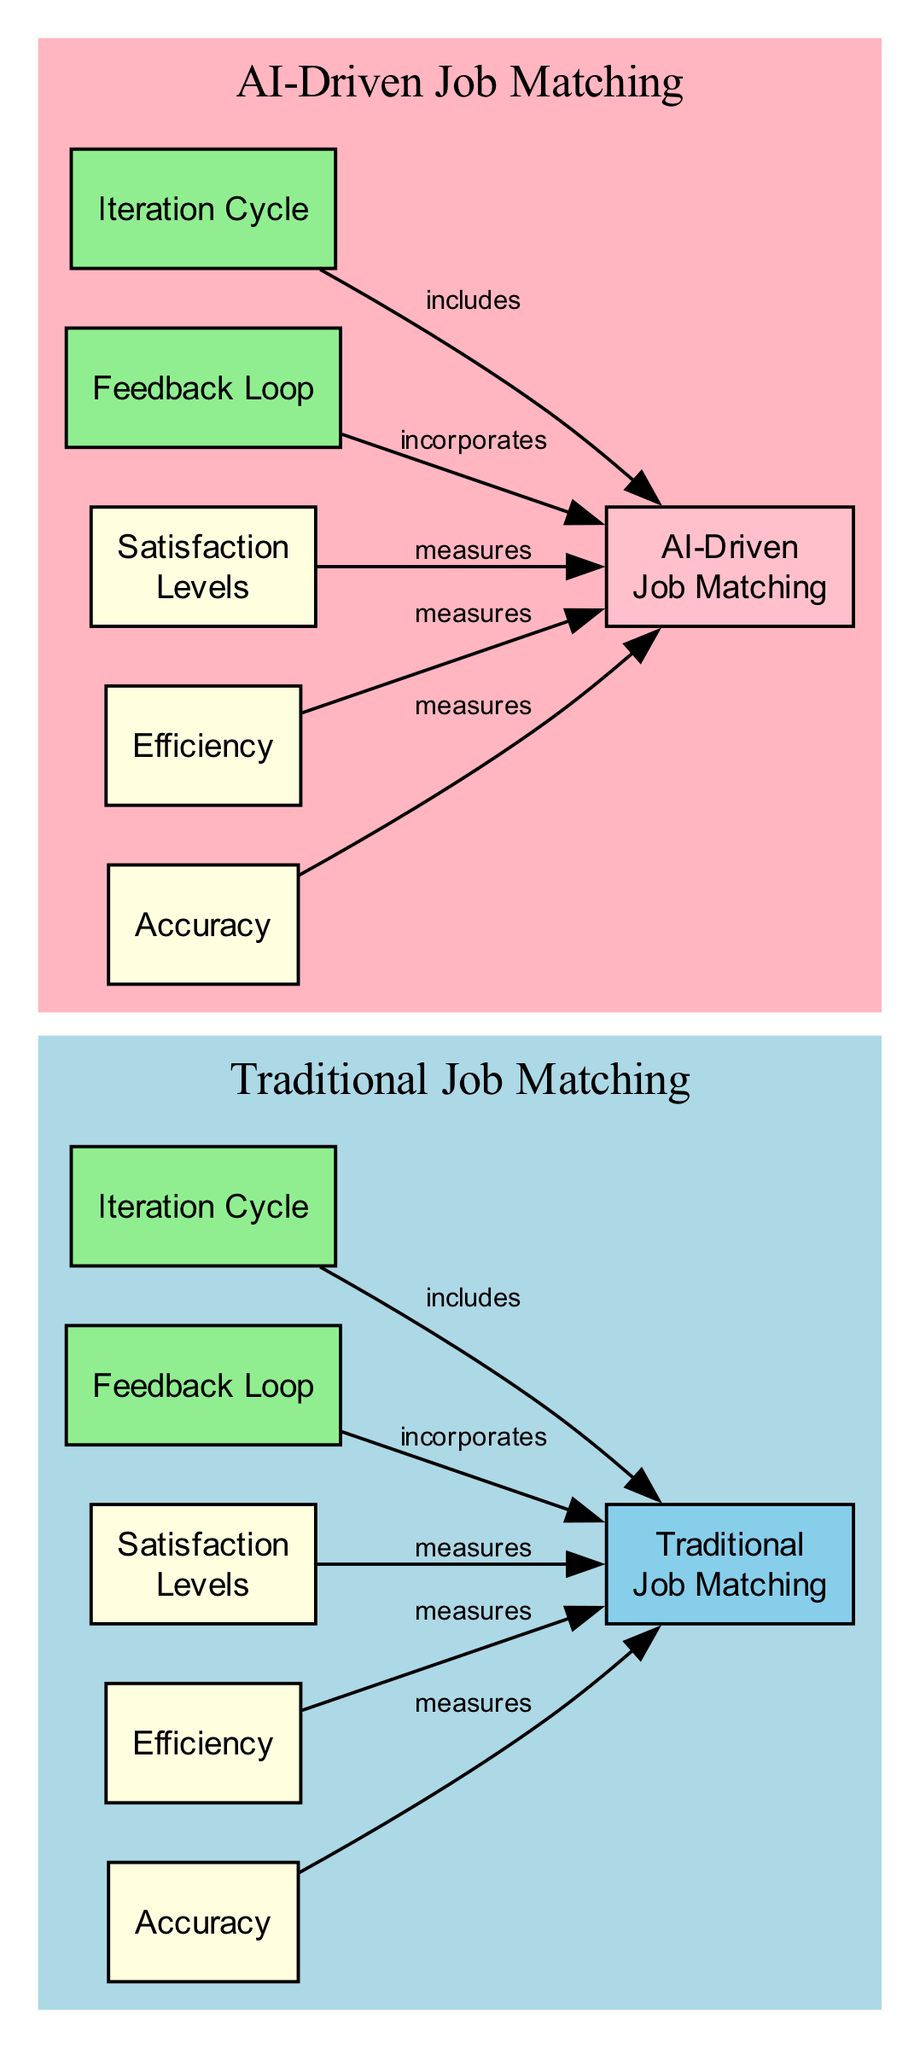What are the two main categories of job matching methods shown in the diagram? The diagram clearly divides job matching methods into two primary categories: "Traditional Job Matching" and "AI-Driven Job Matching." These are represented as separate nodes at the top of the diagram.
Answer: Traditional Job Matching, AI-Driven Job Matching Which node describes the satisfaction levels in traditional job matching? The diagram features a node labeled "Satisfaction Levels" under the "Traditional Job Matching" section. This indicates that it specifically addresses the satisfaction levels associated with traditional methods.
Answer: Satisfaction Levels How many nodes are related to efficiency in job matching? The diagram includes two nodes related to efficiency: "Efficiency Traditional" and "Efficiency AI Driven." These nodes capture the efficiency measures for both traditional and AI methods, leading to a total of 2.
Answer: 2 What type of feedback loop is associated with AI-driven job matching? The diagram shows a node labeled "Feedback Loop" in the "AI-Driven Job Matching" section, indicating the corresponding feedback mechanisms utilized in AI methods.
Answer: Feedback Loop Which cycle is included in traditional job matching methods? The diagram specifies an "Iteration Cycle" node within the "Traditional Job Matching" section, indicating the iterative process employed in traditional methods.
Answer: Iteration Cycle How does the feedback loop in traditional job matching relate to its methods? The "Feedback Loop" node in the traditional section incorporates feedback into "Traditional Job Matching." This illustrates the relationship between the feedback loop and traditional methods as it indicates the way feedback affects those methods.
Answer: incorporates What is depicted as the accuracy measurement for AI-driven systems? The diagram includes a node labeled "Accuracy" under the "AI-Driven Job Matching" section, which specifically refers to the measures of precision in matching candidates to job roles using AI methods.
Answer: Accuracy What is the relationship between the satisfaction levels in AI-driven job matching and its methods? The diagram shows that the "Satisfaction Levels" node under the "AI-Driven Job Matching" incorporates satisfaction metrics into the overall AI-driven methods, highlighting their impact.
Answer: incorporates 